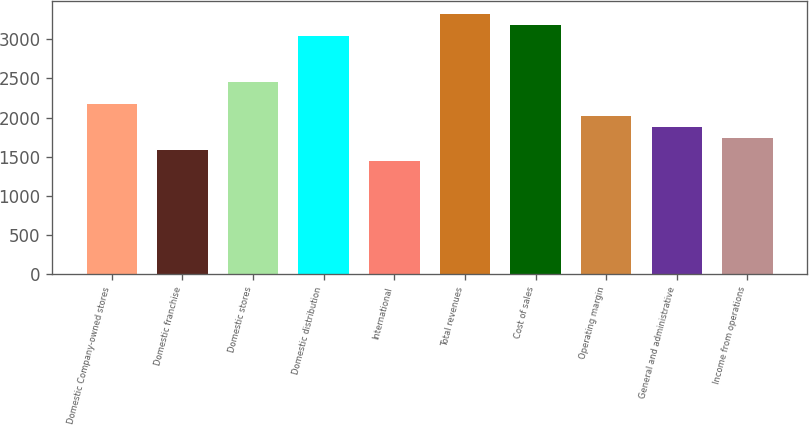Convert chart to OTSL. <chart><loc_0><loc_0><loc_500><loc_500><bar_chart><fcel>Domestic Company-owned stores<fcel>Domestic franchise<fcel>Domestic stores<fcel>Domestic distribution<fcel>International<fcel>Total revenues<fcel>Cost of sales<fcel>Operating margin<fcel>General and administrative<fcel>Income from operations<nl><fcel>2169.65<fcel>1591.13<fcel>2458.91<fcel>3037.43<fcel>1446.5<fcel>3326.69<fcel>3182.06<fcel>2025.02<fcel>1880.39<fcel>1735.76<nl></chart> 